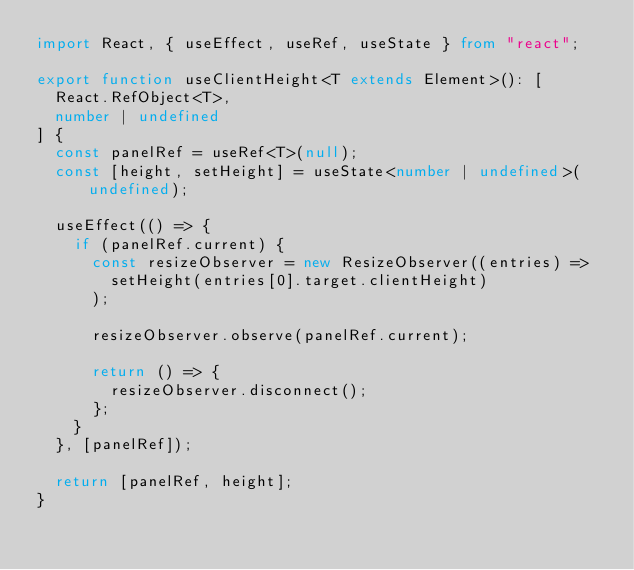Convert code to text. <code><loc_0><loc_0><loc_500><loc_500><_TypeScript_>import React, { useEffect, useRef, useState } from "react";

export function useClientHeight<T extends Element>(): [
  React.RefObject<T>,
  number | undefined
] {
  const panelRef = useRef<T>(null);
  const [height, setHeight] = useState<number | undefined>(undefined);

  useEffect(() => {
    if (panelRef.current) {
      const resizeObserver = new ResizeObserver((entries) =>
        setHeight(entries[0].target.clientHeight)
      );

      resizeObserver.observe(panelRef.current);

      return () => {
        resizeObserver.disconnect();
      };
    }
  }, [panelRef]);

  return [panelRef, height];
}
</code> 